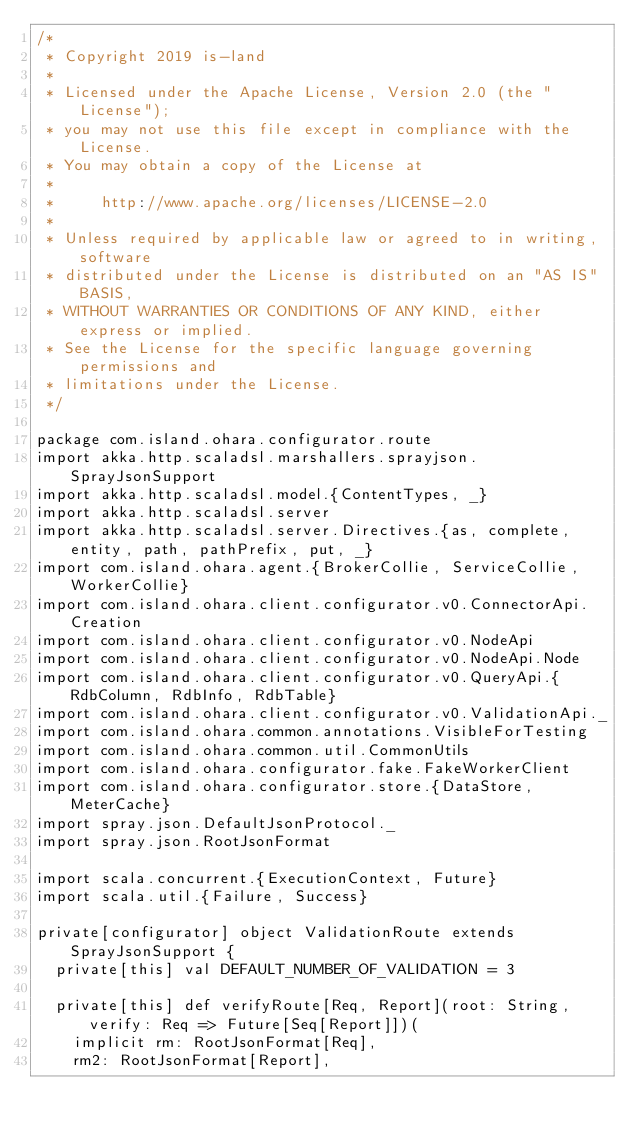<code> <loc_0><loc_0><loc_500><loc_500><_Scala_>/*
 * Copyright 2019 is-land
 *
 * Licensed under the Apache License, Version 2.0 (the "License");
 * you may not use this file except in compliance with the License.
 * You may obtain a copy of the License at
 *
 *     http://www.apache.org/licenses/LICENSE-2.0
 *
 * Unless required by applicable law or agreed to in writing, software
 * distributed under the License is distributed on an "AS IS" BASIS,
 * WITHOUT WARRANTIES OR CONDITIONS OF ANY KIND, either express or implied.
 * See the License for the specific language governing permissions and
 * limitations under the License.
 */

package com.island.ohara.configurator.route
import akka.http.scaladsl.marshallers.sprayjson.SprayJsonSupport
import akka.http.scaladsl.model.{ContentTypes, _}
import akka.http.scaladsl.server
import akka.http.scaladsl.server.Directives.{as, complete, entity, path, pathPrefix, put, _}
import com.island.ohara.agent.{BrokerCollie, ServiceCollie, WorkerCollie}
import com.island.ohara.client.configurator.v0.ConnectorApi.Creation
import com.island.ohara.client.configurator.v0.NodeApi
import com.island.ohara.client.configurator.v0.NodeApi.Node
import com.island.ohara.client.configurator.v0.QueryApi.{RdbColumn, RdbInfo, RdbTable}
import com.island.ohara.client.configurator.v0.ValidationApi._
import com.island.ohara.common.annotations.VisibleForTesting
import com.island.ohara.common.util.CommonUtils
import com.island.ohara.configurator.fake.FakeWorkerClient
import com.island.ohara.configurator.store.{DataStore, MeterCache}
import spray.json.DefaultJsonProtocol._
import spray.json.RootJsonFormat

import scala.concurrent.{ExecutionContext, Future}
import scala.util.{Failure, Success}

private[configurator] object ValidationRoute extends SprayJsonSupport {
  private[this] val DEFAULT_NUMBER_OF_VALIDATION = 3

  private[this] def verifyRoute[Req, Report](root: String, verify: Req => Future[Seq[Report]])(
    implicit rm: RootJsonFormat[Req],
    rm2: RootJsonFormat[Report],</code> 